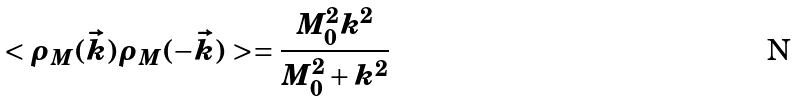Convert formula to latex. <formula><loc_0><loc_0><loc_500><loc_500>< \rho _ { M } ( \vec { k } ) \rho _ { M } ( - \vec { k } ) > = \frac { M _ { 0 } ^ { 2 } k ^ { 2 } } { M _ { 0 } ^ { 2 } + k ^ { 2 } }</formula> 